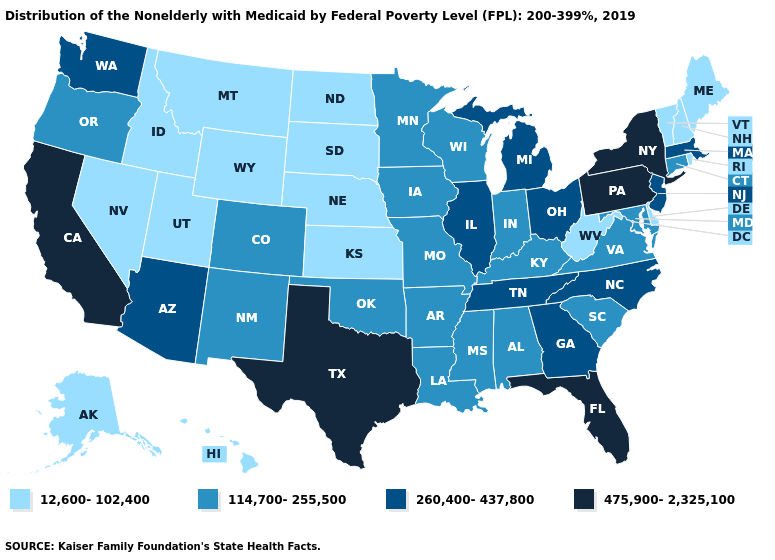What is the highest value in states that border Kansas?
Be succinct. 114,700-255,500. Is the legend a continuous bar?
Quick response, please. No. Name the states that have a value in the range 475,900-2,325,100?
Answer briefly. California, Florida, New York, Pennsylvania, Texas. Which states have the lowest value in the West?
Short answer required. Alaska, Hawaii, Idaho, Montana, Nevada, Utah, Wyoming. What is the lowest value in the USA?
Answer briefly. 12,600-102,400. What is the lowest value in the USA?
Give a very brief answer. 12,600-102,400. Name the states that have a value in the range 12,600-102,400?
Be succinct. Alaska, Delaware, Hawaii, Idaho, Kansas, Maine, Montana, Nebraska, Nevada, New Hampshire, North Dakota, Rhode Island, South Dakota, Utah, Vermont, West Virginia, Wyoming. What is the value of Florida?
Answer briefly. 475,900-2,325,100. What is the value of Hawaii?
Short answer required. 12,600-102,400. Name the states that have a value in the range 260,400-437,800?
Write a very short answer. Arizona, Georgia, Illinois, Massachusetts, Michigan, New Jersey, North Carolina, Ohio, Tennessee, Washington. Does Hawaii have a lower value than Arkansas?
Be succinct. Yes. What is the value of Kansas?
Short answer required. 12,600-102,400. Name the states that have a value in the range 12,600-102,400?
Keep it brief. Alaska, Delaware, Hawaii, Idaho, Kansas, Maine, Montana, Nebraska, Nevada, New Hampshire, North Dakota, Rhode Island, South Dakota, Utah, Vermont, West Virginia, Wyoming. Does Florida have the highest value in the South?
Answer briefly. Yes. Does Florida have the highest value in the South?
Write a very short answer. Yes. 